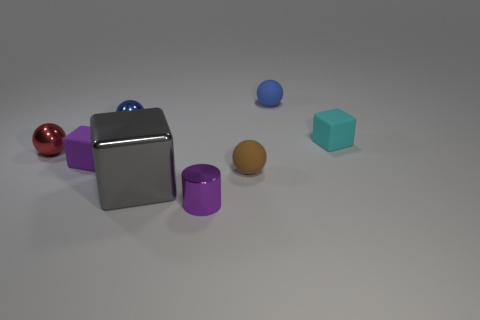Add 2 purple metallic cylinders. How many objects exist? 10 Subtract all cylinders. How many objects are left? 7 Subtract all purple blocks. Subtract all rubber objects. How many objects are left? 3 Add 4 small purple matte cubes. How many small purple matte cubes are left? 5 Add 2 small things. How many small things exist? 9 Subtract 0 red blocks. How many objects are left? 8 